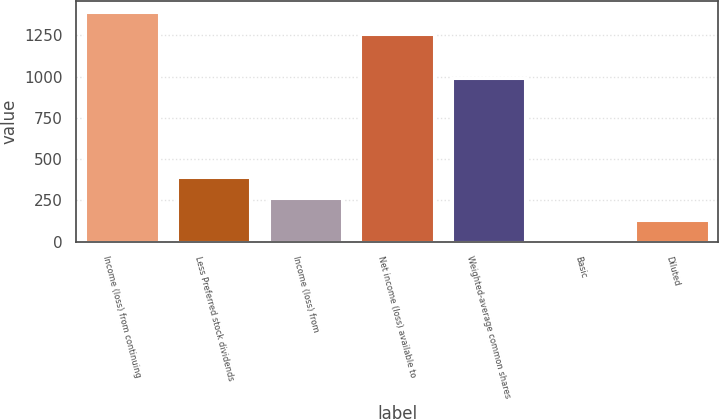Convert chart. <chart><loc_0><loc_0><loc_500><loc_500><bar_chart><fcel>Income (loss) from continuing<fcel>Less Preferred stock dividends<fcel>Income (loss) from<fcel>Net income (loss) available to<fcel>Weighted-average common shares<fcel>Basic<fcel>Diluted<nl><fcel>1391.27<fcel>392.13<fcel>261.86<fcel>1261<fcel>989<fcel>1.32<fcel>131.59<nl></chart> 